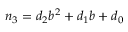Convert formula to latex. <formula><loc_0><loc_0><loc_500><loc_500>n _ { 3 } = d _ { 2 } b ^ { 2 } + d _ { 1 } b + d _ { 0 }</formula> 